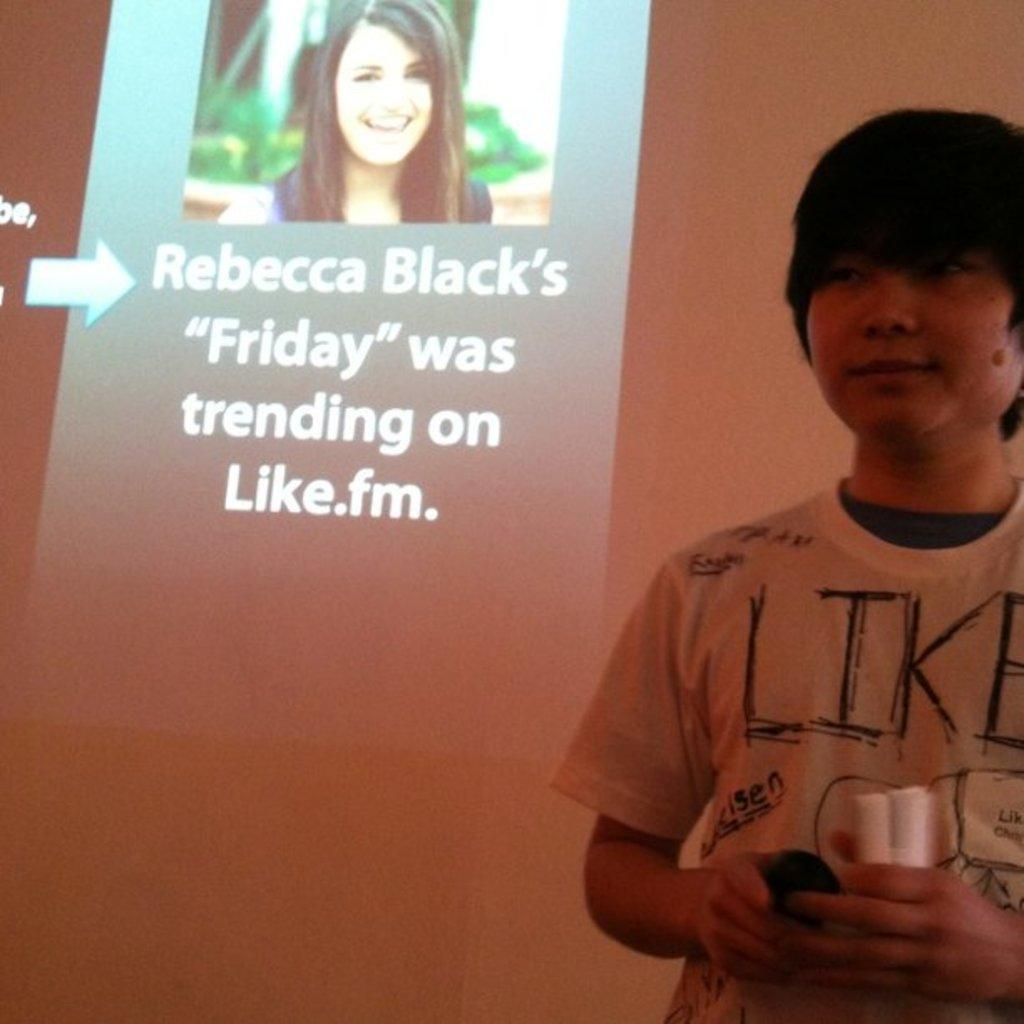What is the main subject of the image? There is a man standing in the image. What can be seen in the background of the image? There is a screen in the background of the image. What is displayed on the screen? Text is present on the screen, and there is also a picture on the screen. How many eggs are being transported by the lumber in the image? There is no lumber or eggs present in the image. 